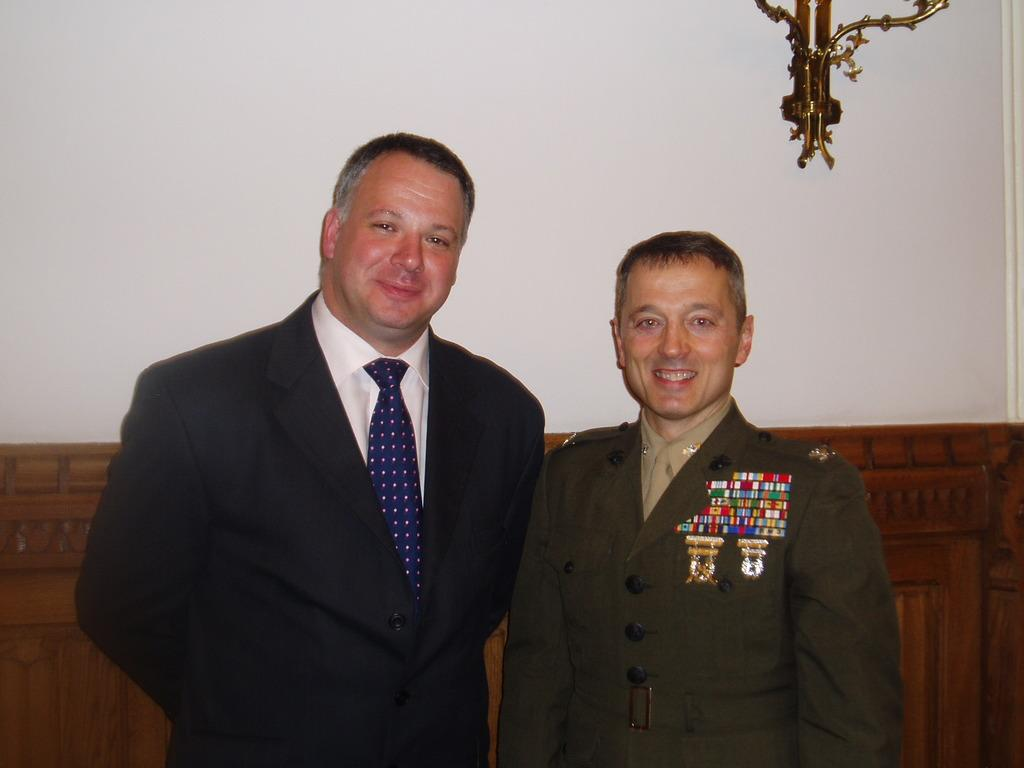How many people are in the image? There are two men in the image. What expressions do the men have in the image? The men are smiling in the image. What is located behind the men in the image? There is a wall behind the men in the image. What type of object can be seen in the image that is made of wood? There is a wooden object in the image. What is the design on the stand at the top of the image? There is a stand with designs at the top of the image. What type of comb is being used to distribute the veins in the image? There is no comb or veins present in the image; it features two men smiling with a wall and a wooden object in the background. 